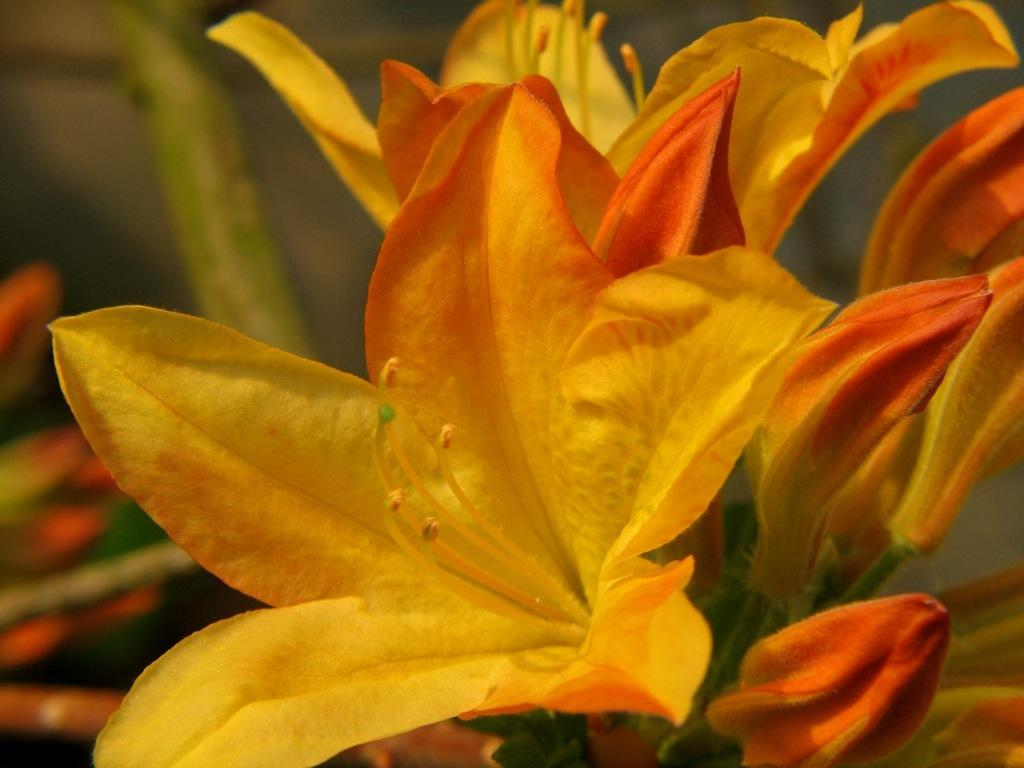What is present in the image? There are flowers in the image. Can you describe the background of the image? The background of the image is blurry. Is there a woman sitting on a metal seat in the image? No, there is no woman or metal seat present in the image; it only features flowers and a blurry background. 